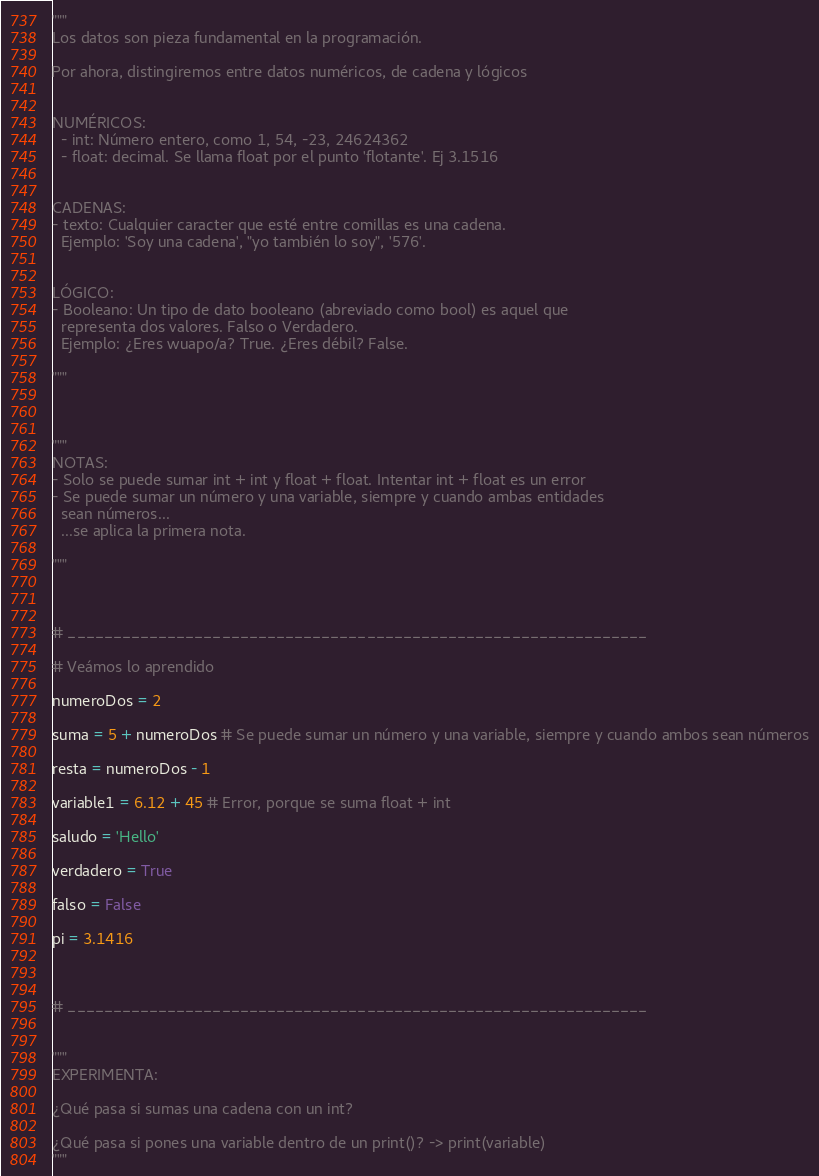<code> <loc_0><loc_0><loc_500><loc_500><_Python_>"""
Los datos son pieza fundamental en la programación.

Por ahora, distingiremos entre datos numéricos, de cadena y lógicos


NUMÉRICOS:
  - int: Número entero, como 1, 54, -23, 24624362
  - float: decimal. Se llama float por el punto 'flotante'. Ej 3.1516


CADENAS:
- texto: Cualquier caracter que esté entre comillas es una cadena.
  Ejemplo: 'Soy una cadena', "yo también lo soy", '576'.


LÓGICO:
- Booleano: Un tipo de dato booleano (abreviado como bool) es aquel que
  representa dos valores. Falso o Verdadero.
  Ejemplo: ¿Eres wuapo/a? True. ¿Eres débil? False.

"""



"""
NOTAS:
- Solo se puede sumar int + int y float + float. Intentar int + float es un error
- Se puede sumar un número y una variable, siempre y cuando ambas entidades
  sean números...
  ...se aplica la primera nota.
  
"""



# ________________________________________________________________

# Veámos lo aprendido

numeroDos = 2

suma = 5 + numeroDos # Se puede sumar un número y una variable, siempre y cuando ambos sean números

resta = numeroDos - 1

variable1 = 6.12 + 45 # Error, porque se suma float + int

saludo = 'Hello'

verdadero = True

falso = False

pi = 3.1416



# ________________________________________________________________


"""
EXPERIMENTA:

¿Qué pasa si sumas una cadena con un int?

¿Qué pasa si pones una variable dentro de un print()? -> print(variable)
"""</code> 